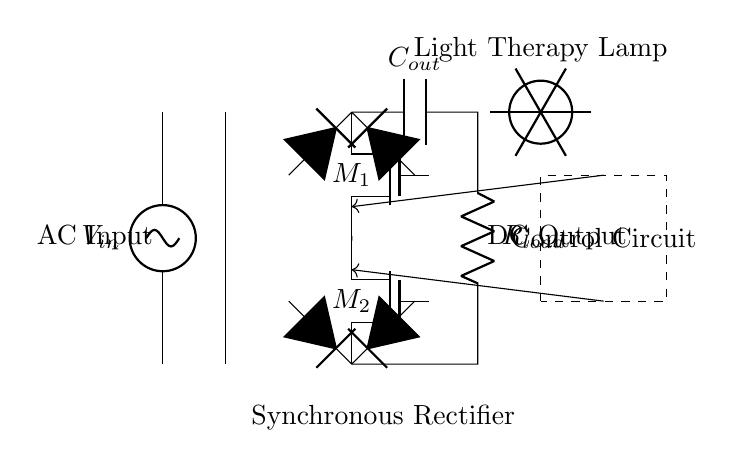What is the input source of this circuit? The input source is an alternating current voltage (AC), as indicated by the symbol for AC voltage in the diagram.
Answer: AC Input What type of rectifier is being used in the circuit? The circuit utilizes a synchronous rectifier, identifiable by the use of MOSFETs for the rectification process, which enhances efficiency compared to a traditional diode-based rectifier.
Answer: Synchronous Rectifier How many MOSFETs are present in the circuit? The diagram shows two MOSFETs, labeled M1 and M2, both positioned to handle the rectifying process in a synchronous manner.
Answer: 2 What is the purpose of the output capacitor? The output capacitor, labeled C_out, smooths the rectified output to provide a steady direct current (DC) voltage for the load connected to the circuit.
Answer: Smoothing What type of load is connected to this circuit? The load, labeled R_load, is a resistive load that represents the light therapy lamp, dissipating power and allowing light therapy to function effectively.
Answer: Resistive Load What role does the control circuit play in this rectifier setup? The control circuit manages the gate signals for the MOSFETs, ensuring that they operate at the right times during the AC cycle for optimal rectification efficiency.
Answer: Control Signals 